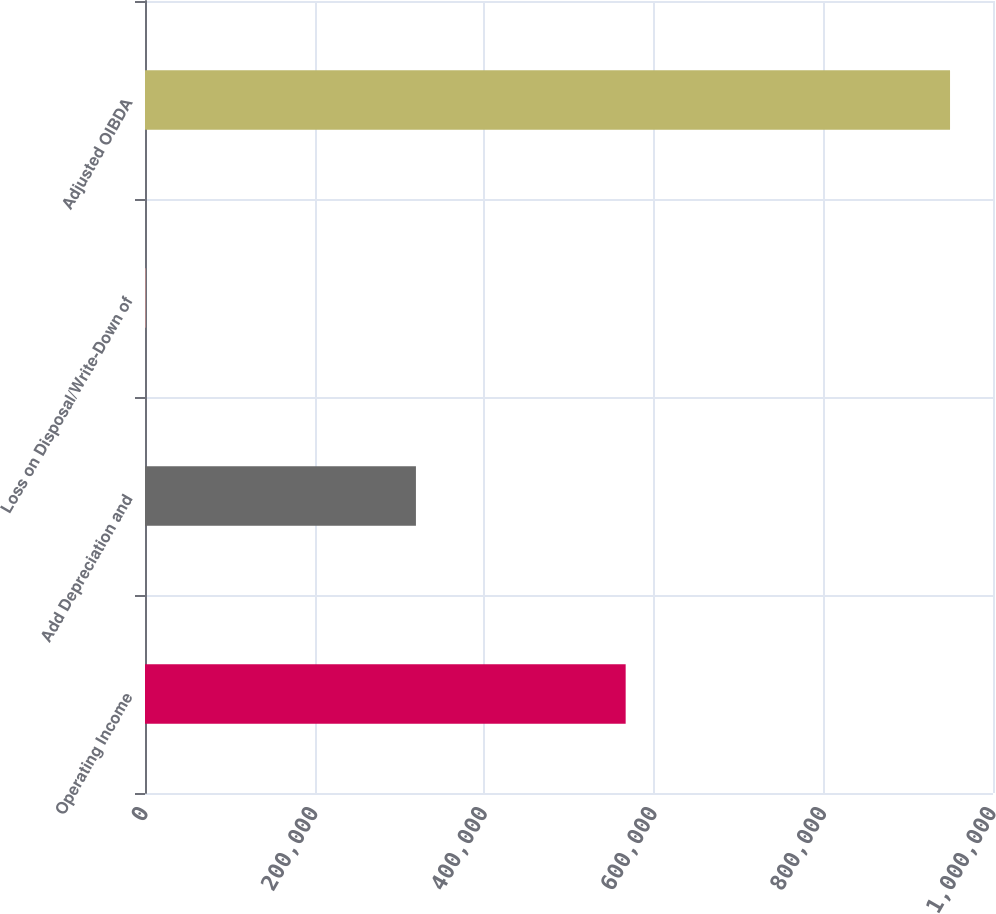Convert chart to OTSL. <chart><loc_0><loc_0><loc_500><loc_500><bar_chart><fcel>Operating Income<fcel>Add Depreciation and<fcel>Loss on Disposal/Write-Down of<fcel>Adjusted OIBDA<nl><fcel>566818<fcel>319499<fcel>995<fcel>949339<nl></chart> 